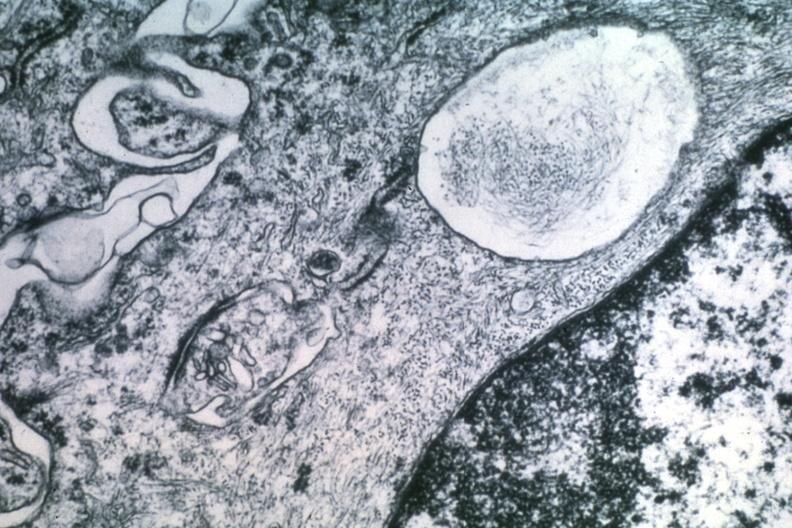what does this image show?
Answer the question using a single word or phrase. Dr garcia tumors 47 